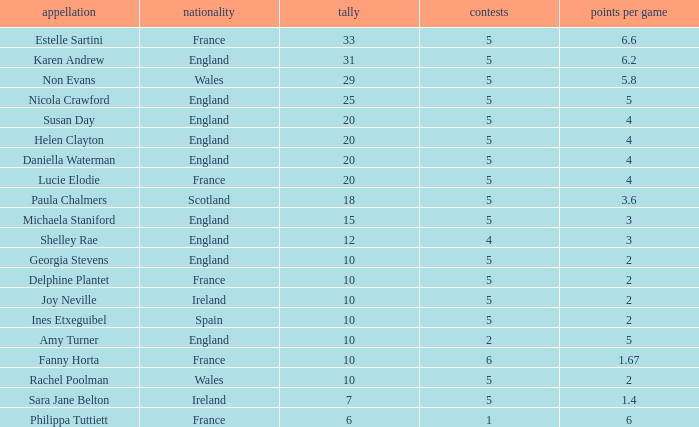Can you tell me the average Points that has a Pts/game larger than 4, and the Nation of england, and the Games smaller than 5? 10.0. Would you mind parsing the complete table? {'header': ['appellation', 'nationality', 'tally', 'contests', 'points per game'], 'rows': [['Estelle Sartini', 'France', '33', '5', '6.6'], ['Karen Andrew', 'England', '31', '5', '6.2'], ['Non Evans', 'Wales', '29', '5', '5.8'], ['Nicola Crawford', 'England', '25', '5', '5'], ['Susan Day', 'England', '20', '5', '4'], ['Helen Clayton', 'England', '20', '5', '4'], ['Daniella Waterman', 'England', '20', '5', '4'], ['Lucie Elodie', 'France', '20', '5', '4'], ['Paula Chalmers', 'Scotland', '18', '5', '3.6'], ['Michaela Staniford', 'England', '15', '5', '3'], ['Shelley Rae', 'England', '12', '4', '3'], ['Georgia Stevens', 'England', '10', '5', '2'], ['Delphine Plantet', 'France', '10', '5', '2'], ['Joy Neville', 'Ireland', '10', '5', '2'], ['Ines Etxeguibel', 'Spain', '10', '5', '2'], ['Amy Turner', 'England', '10', '2', '5'], ['Fanny Horta', 'France', '10', '6', '1.67'], ['Rachel Poolman', 'Wales', '10', '5', '2'], ['Sara Jane Belton', 'Ireland', '7', '5', '1.4'], ['Philippa Tuttiett', 'France', '6', '1', '6']]} 